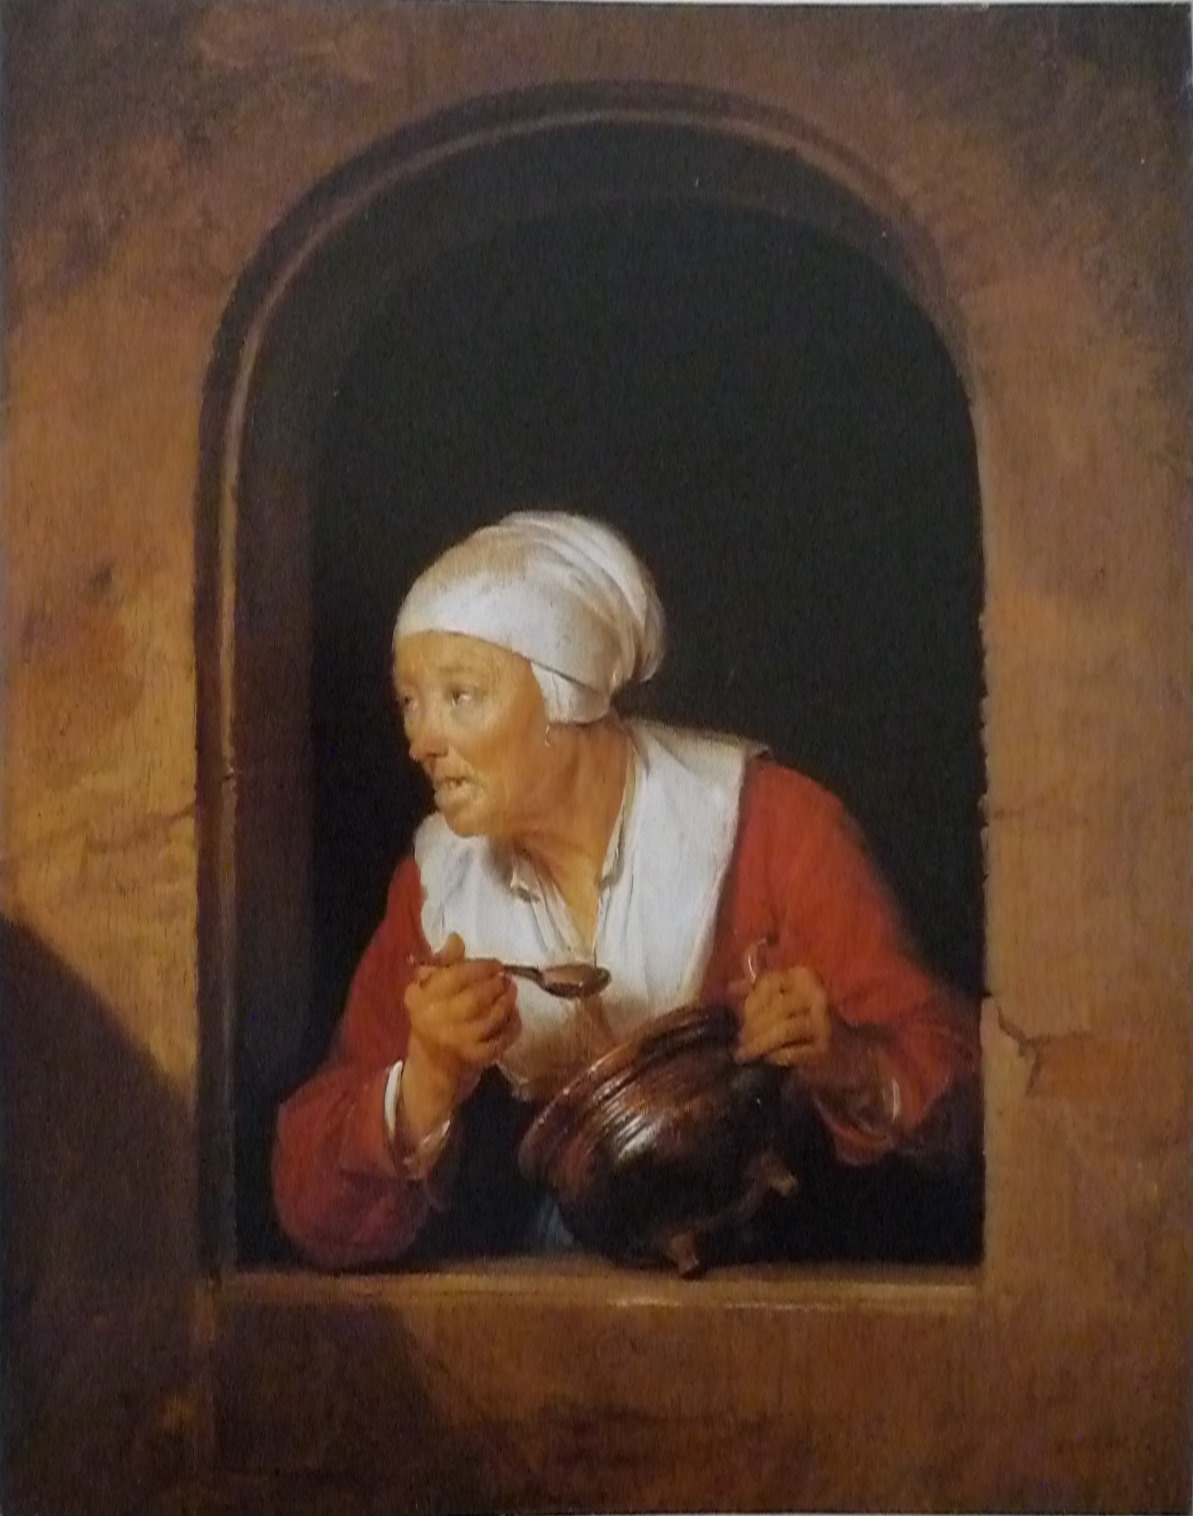Is there anything about the lighting and use of contrast in the image that stands out? The artist has employed a dramatic use of chiaroscuro, a technique where stark contrasts between light and dark areas enhance the three-dimensional illusion and draw attention to certain elements. Here, the woman's face and upper body are illuminated, emerging from the shadowy environment, which highlights her expression and the interaction with the jug and bowl. This technique could suggest that the artist intended to focus on a moment of emotional or narrative significance. 